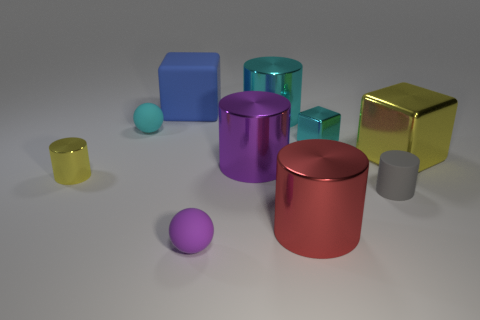Subtract all small gray cylinders. How many cylinders are left? 4 Subtract 3 cylinders. How many cylinders are left? 2 Subtract all cyan balls. How many balls are left? 1 Add 2 tiny purple balls. How many tiny purple balls exist? 3 Subtract 0 blue balls. How many objects are left? 10 Subtract all blocks. How many objects are left? 7 Subtract all yellow cubes. Subtract all purple spheres. How many cubes are left? 2 Subtract all purple cubes. How many cyan cylinders are left? 1 Subtract all tiny cyan spheres. Subtract all big rubber blocks. How many objects are left? 8 Add 3 large purple things. How many large purple things are left? 4 